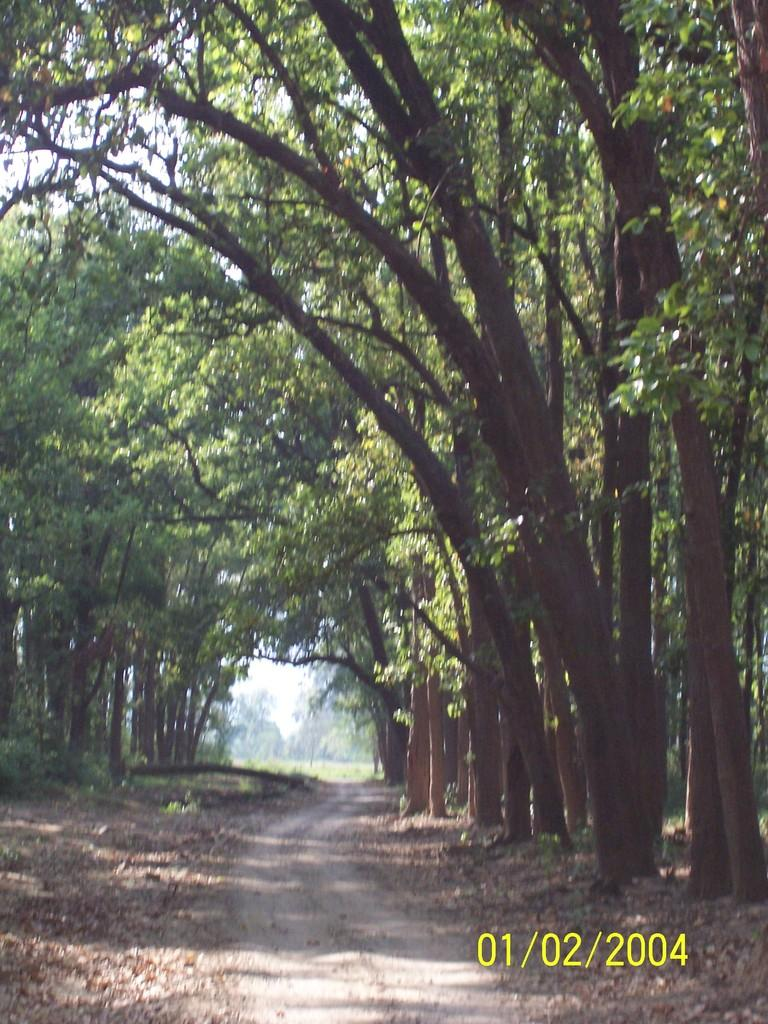What is located at the bottom of the image? There is a road at the bottom of the image. What can be seen on both sides of the road? There are many trees on both sides of the road. What type of hat is the ocean wearing in the image? There is no hat or ocean present in the image; it features a road with trees on both sides. 